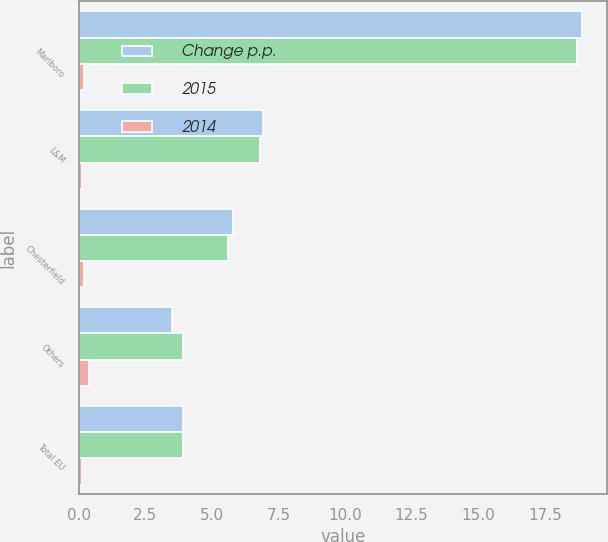Convert chart to OTSL. <chart><loc_0><loc_0><loc_500><loc_500><stacked_bar_chart><ecel><fcel>Marlboro<fcel>L&M<fcel>Chesterfield<fcel>Others<fcel>Total EU<nl><fcel>Change p.p.<fcel>18.9<fcel>6.9<fcel>5.8<fcel>3.5<fcel>3.9<nl><fcel>2015<fcel>18.7<fcel>6.8<fcel>5.6<fcel>3.9<fcel>3.9<nl><fcel>2014<fcel>0.2<fcel>0.1<fcel>0.2<fcel>0.4<fcel>0.1<nl></chart> 